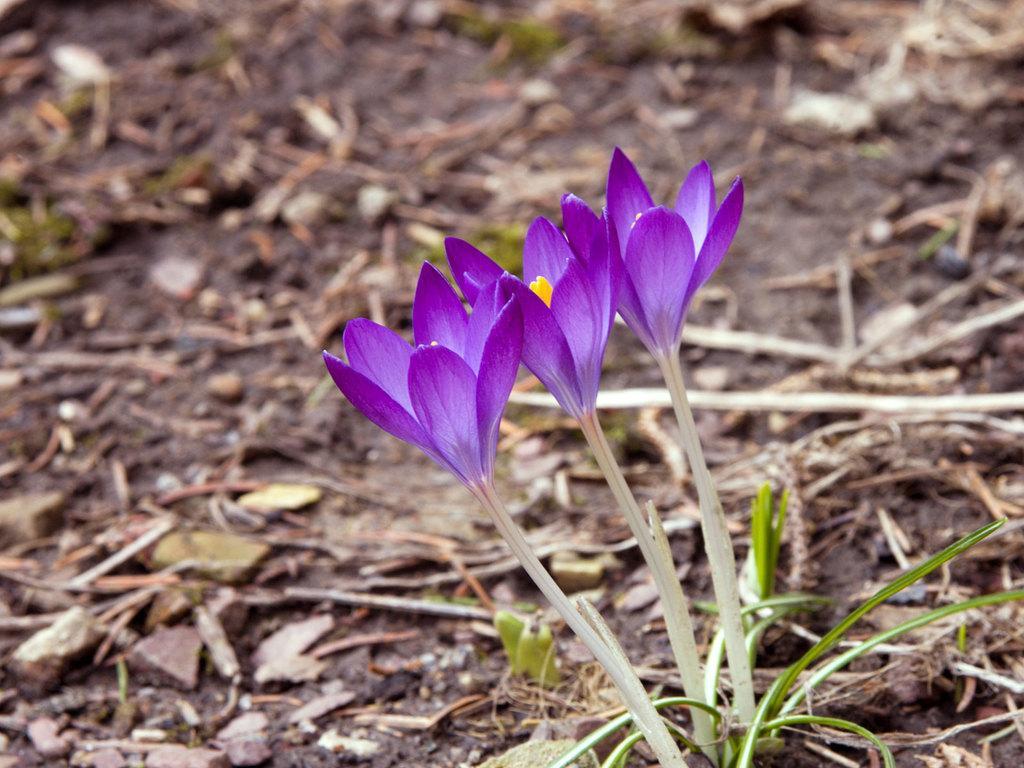Can you describe this image briefly? In this image I see flowers which are of purple and yellow in color and I see the grass and I see that it is blurred in the background. 